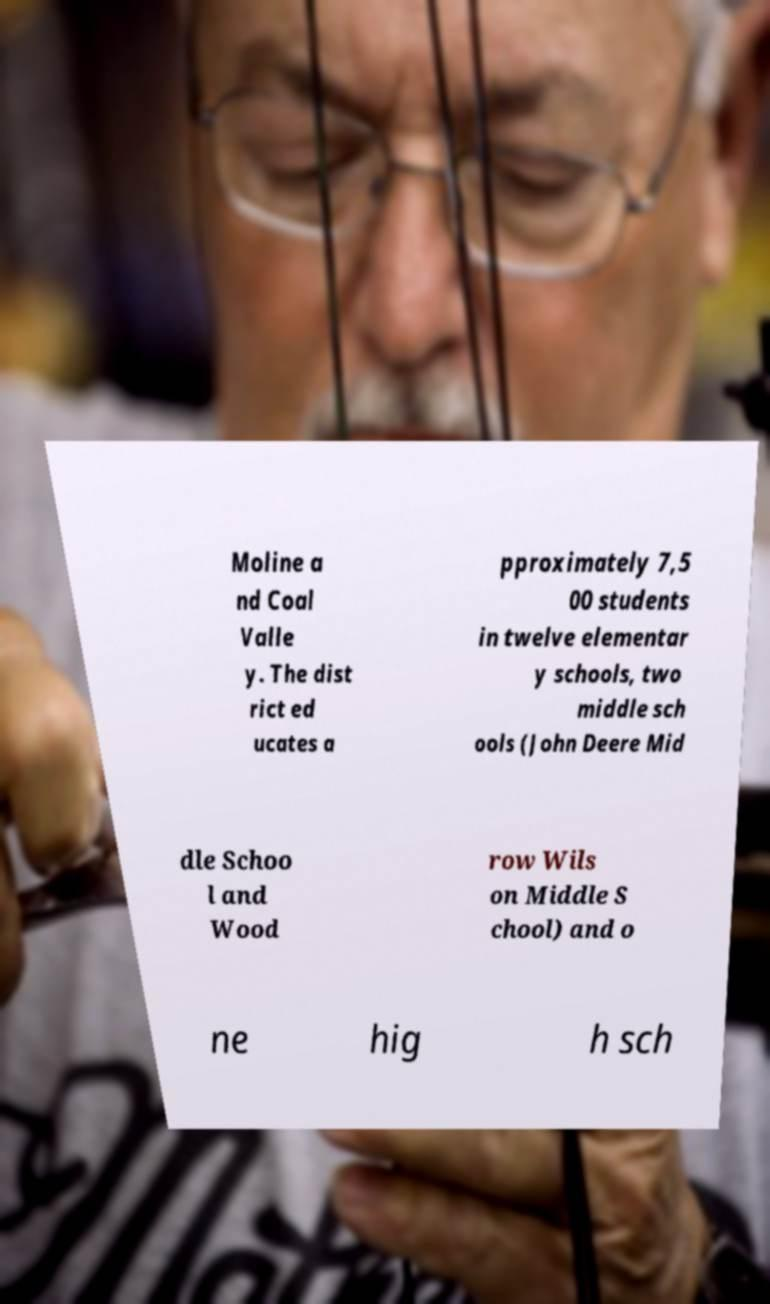Please read and relay the text visible in this image. What does it say? Moline a nd Coal Valle y. The dist rict ed ucates a pproximately 7,5 00 students in twelve elementar y schools, two middle sch ools (John Deere Mid dle Schoo l and Wood row Wils on Middle S chool) and o ne hig h sch 